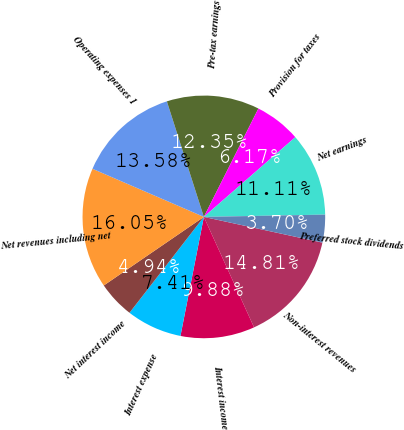Convert chart. <chart><loc_0><loc_0><loc_500><loc_500><pie_chart><fcel>Non-interest revenues<fcel>Interest income<fcel>Interest expense<fcel>Net interest income<fcel>Net revenues including net<fcel>Operating expenses 1<fcel>Pre-tax earnings<fcel>Provision for taxes<fcel>Net earnings<fcel>Preferred stock dividends<nl><fcel>14.81%<fcel>9.88%<fcel>7.41%<fcel>4.94%<fcel>16.05%<fcel>13.58%<fcel>12.35%<fcel>6.17%<fcel>11.11%<fcel>3.7%<nl></chart> 